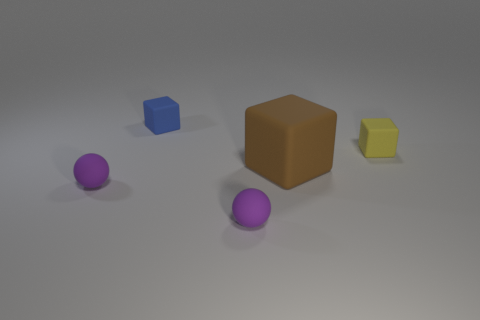Subtract all small cubes. How many cubes are left? 1 Subtract all blue blocks. How many blocks are left? 2 Add 5 matte things. How many objects exist? 10 Subtract 3 blocks. How many blocks are left? 0 Subtract all blocks. How many objects are left? 2 Subtract 0 yellow balls. How many objects are left? 5 Subtract all brown blocks. Subtract all brown spheres. How many blocks are left? 2 Subtract all small balls. Subtract all big brown things. How many objects are left? 2 Add 3 small purple things. How many small purple things are left? 5 Add 3 yellow rubber objects. How many yellow rubber objects exist? 4 